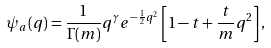<formula> <loc_0><loc_0><loc_500><loc_500>\psi _ { a } ( q ) = \frac { 1 } { \Gamma ( m ) } q ^ { \gamma } e ^ { - \frac { 1 } { 2 } q ^ { 2 } } \left [ 1 - t + \frac { t } { m } q ^ { 2 } \right ] ,</formula> 